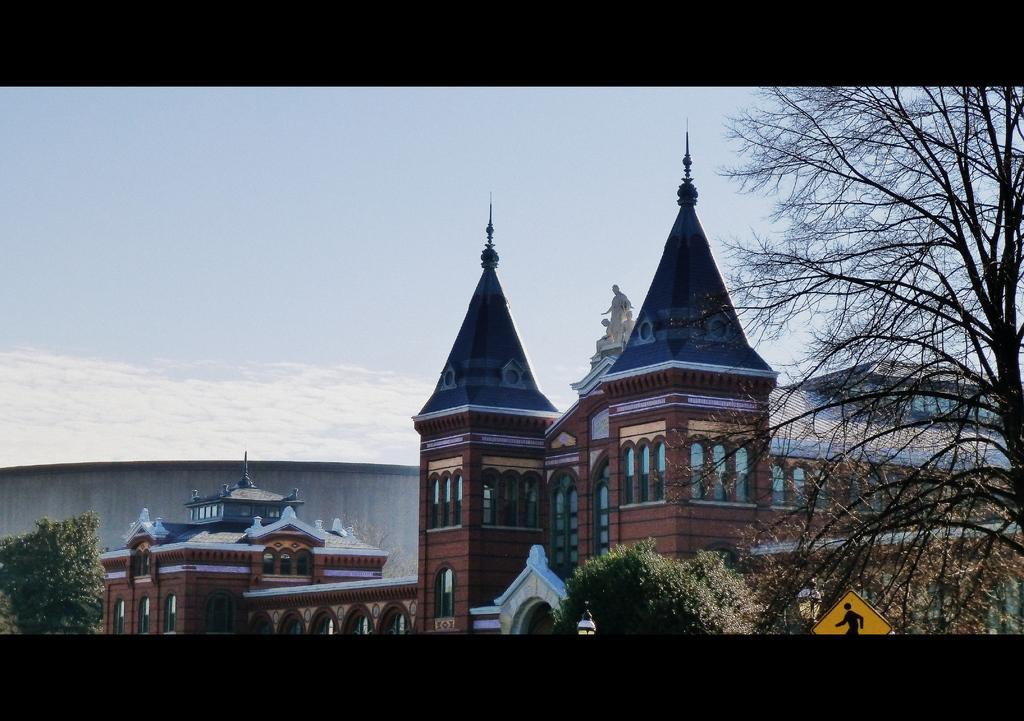Can you describe this image briefly? In the foreground of picture there are trees, sign board, street light and a building. On the left there is a tree. Sky is sunny. 